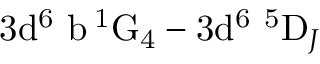<formula> <loc_0><loc_0><loc_500><loc_500>3 d ^ { 6 } \ b \, ^ { 1 } G _ { 4 } - 3 d ^ { 6 } \ ^ { 5 } D _ { J }</formula> 